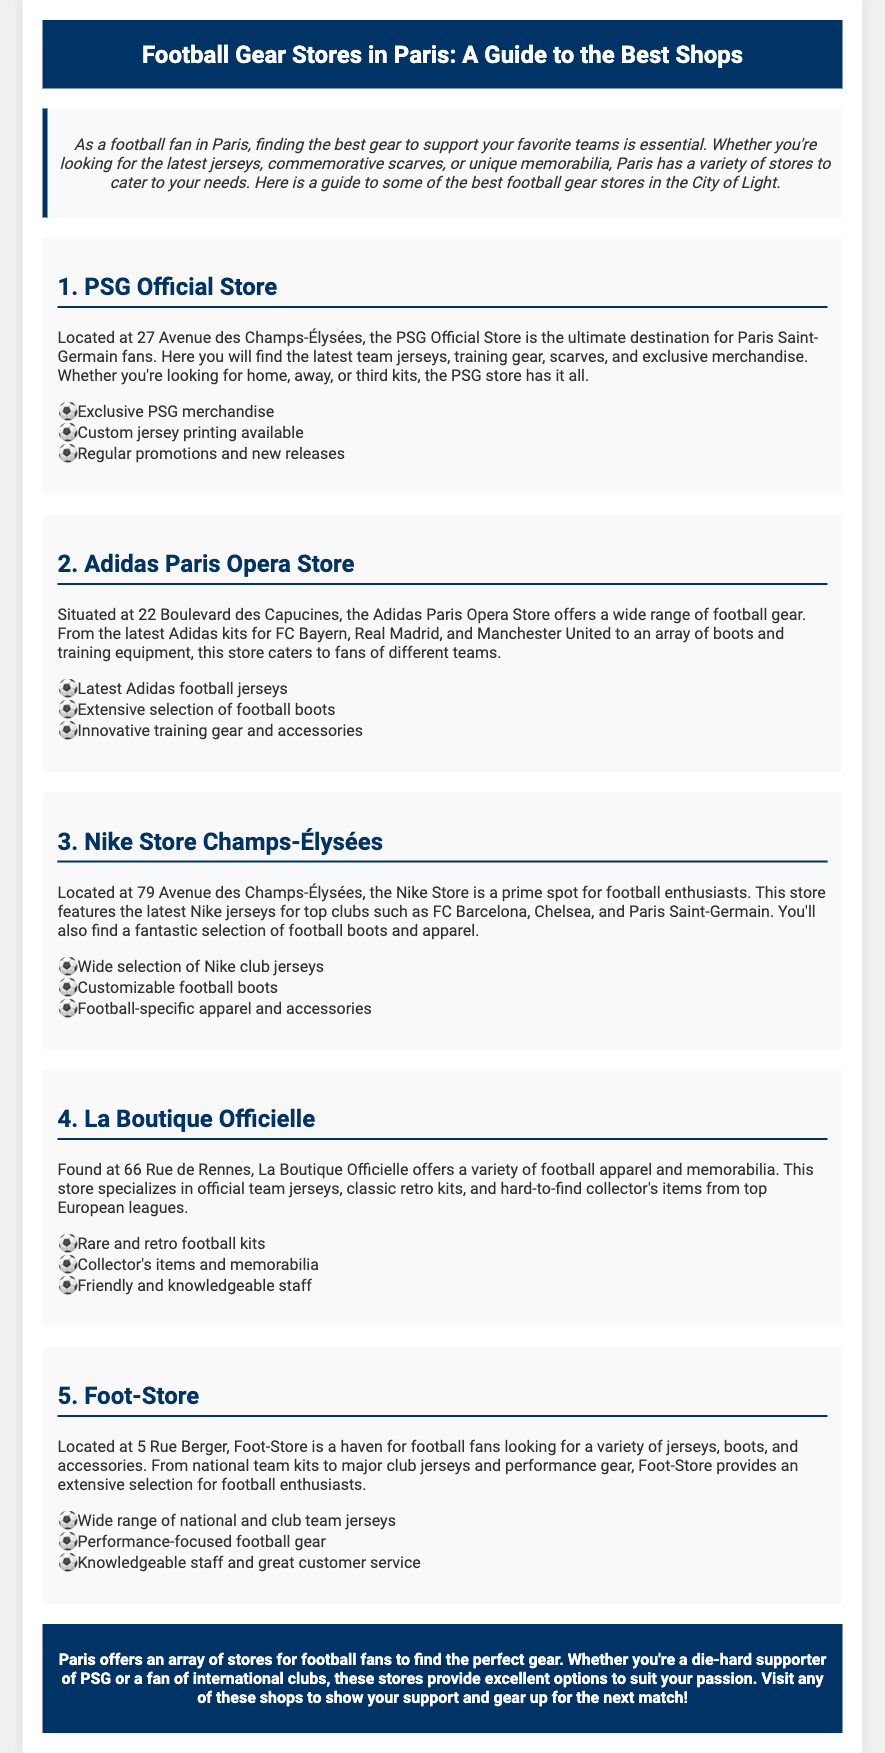What is the location of the PSG Official Store? The document states that the PSG Official Store is located at 27 Avenue des Champs-Élysées.
Answer: 27 Avenue des Champs-Élysées What type of merchandise does the Adidas Paris Opera Store offer? The document mentions that the Adidas Paris Opera Store offers a wide range of football gear, including Adidas kits and training equipment.
Answer: Adidas kits and training equipment How many highlights are listed for the Nike Store? The document lists three highlights for the Nike Store: a selection of jerseys, custom boots, and apparel.
Answer: Three Which store specializes in rare and retro football kits? According to the document, La Boutique Officielle specializes in rare and retro football kits and memorabilia.
Answer: La Boutique Officielle What are the main types of products available at Foot-Store? The document states that Foot-Store provides a variety of jerseys, boots, and performance gear.
Answer: Jerseys, boots, and performance gear What color is the header of the flyer? The document describes the header color as dark navy blue (003366).
Answer: Dark navy blue What position does the PSG Official Store hold in the list? The store is the first in the list of football gear stores mentioned in the document.
Answer: First Which football club does the Nike Store feature merchandise for? The document lists FC Barcelona, Chelsea, and Paris Saint-Germain as clubs with merchandise at the Nike Store.
Answer: FC Barcelona, Chelsea, Paris Saint-Germain What feature regarding jerseys is available at the PSG Official Store? The document states that custom jersey printing is available at the PSG Official Store.
Answer: Custom jersey printing 